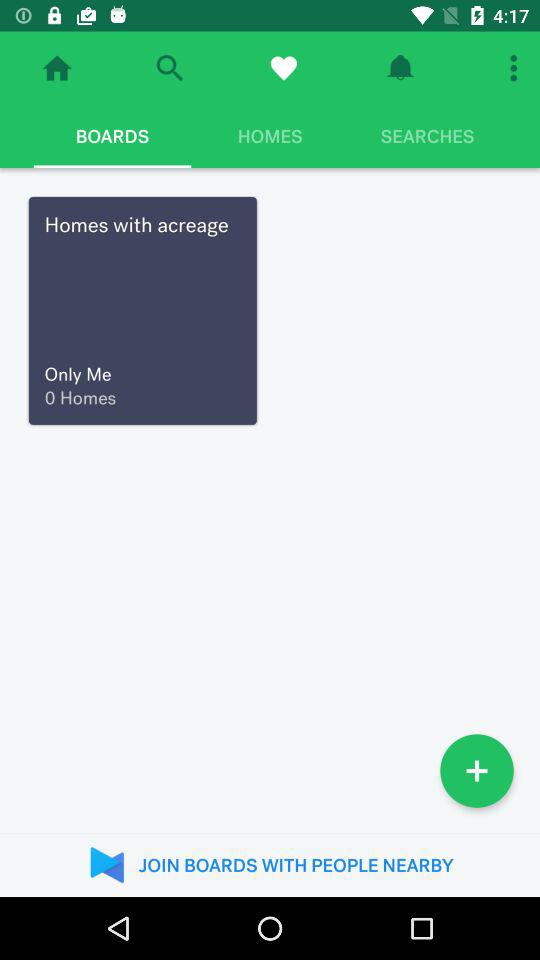What is the selected tab? The selected tab is "BOARDS". 